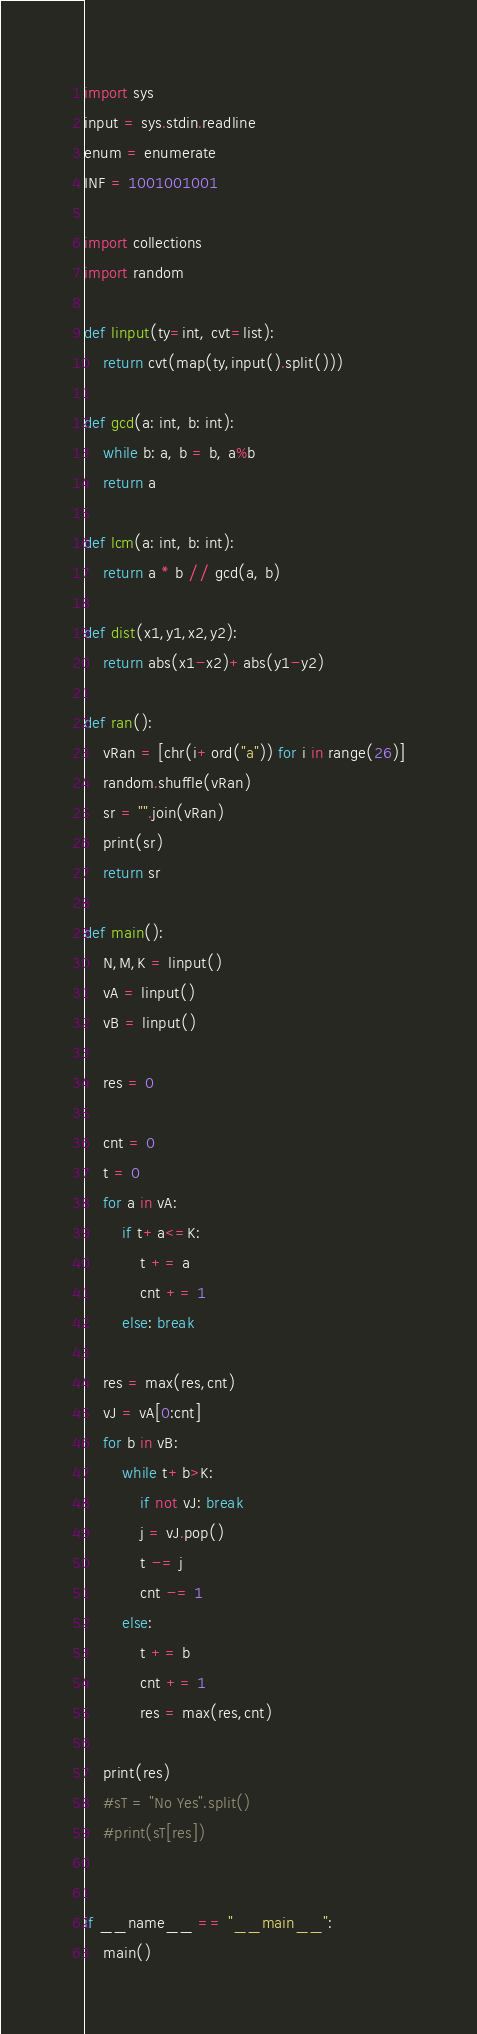Convert code to text. <code><loc_0><loc_0><loc_500><loc_500><_Python_>import sys
input = sys.stdin.readline
enum = enumerate
INF = 1001001001

import collections
import random

def linput(ty=int, cvt=list):
	return cvt(map(ty,input().split()))

def gcd(a: int, b: int):
	while b: a, b = b, a%b
	return a

def lcm(a: int, b: int):
	return a * b // gcd(a, b)

def dist(x1,y1,x2,y2):
	return abs(x1-x2)+abs(y1-y2)

def ran():
	vRan = [chr(i+ord("a")) for i in range(26)]
	random.shuffle(vRan)
	sr = "".join(vRan)
	print(sr)
	return sr

def main():
	N,M,K = linput()
	vA = linput()
	vB = linput()
	
	res = 0
	
	cnt = 0
	t = 0
	for a in vA:
		if t+a<=K:
			t += a
			cnt += 1
		else: break
	
	res = max(res,cnt)
	vJ = vA[0:cnt]
	for b in vB:
		while t+b>K:
			if not vJ: break
			j = vJ.pop()
			t -= j
			cnt -= 1
		else:
			t += b
			cnt += 1
			res = max(res,cnt)
	
	print(res)
	#sT = "No Yes".split()
	#print(sT[res])
	

if __name__ == "__main__":
	main()
</code> 